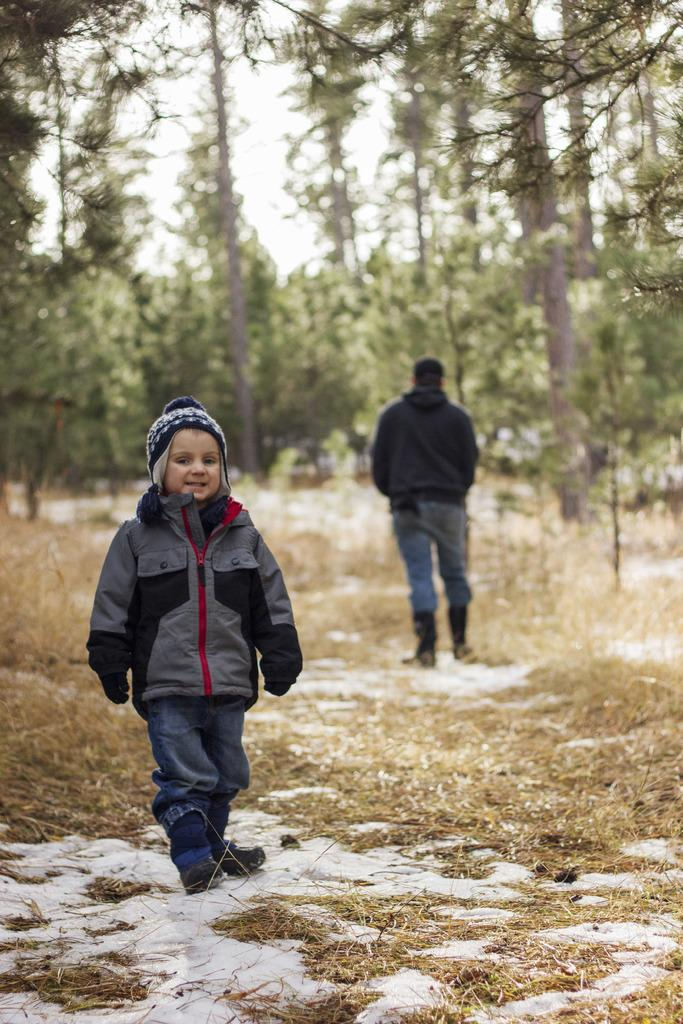What is the main subject of the image? There is a child in the image. What is the child wearing? The child is wearing a jacket, gloves, and a cap. What is the child's posture in the image? The child is standing. Can you describe the background of the image? There are trees and another person in the background of the image. What is the ground covered with in the image? The ground is covered with grasses. How does the bean compare to the clam in the image? There are no beans or clams present in the image. 